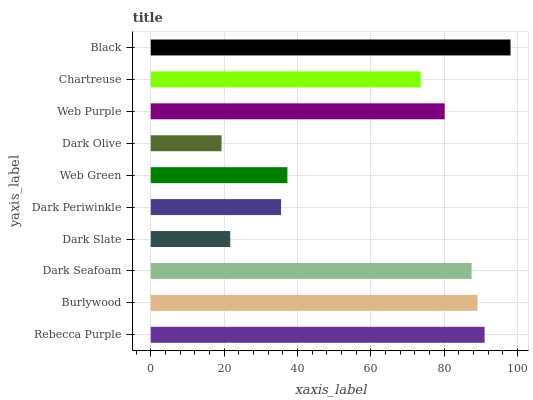Is Dark Olive the minimum?
Answer yes or no. Yes. Is Black the maximum?
Answer yes or no. Yes. Is Burlywood the minimum?
Answer yes or no. No. Is Burlywood the maximum?
Answer yes or no. No. Is Rebecca Purple greater than Burlywood?
Answer yes or no. Yes. Is Burlywood less than Rebecca Purple?
Answer yes or no. Yes. Is Burlywood greater than Rebecca Purple?
Answer yes or no. No. Is Rebecca Purple less than Burlywood?
Answer yes or no. No. Is Web Purple the high median?
Answer yes or no. Yes. Is Chartreuse the low median?
Answer yes or no. Yes. Is Dark Seafoam the high median?
Answer yes or no. No. Is Dark Seafoam the low median?
Answer yes or no. No. 